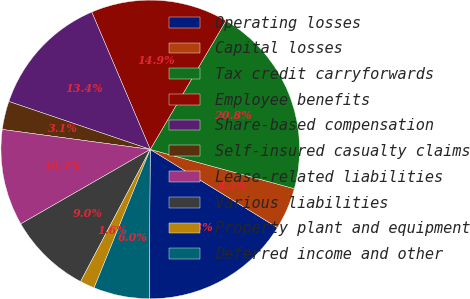Convert chart. <chart><loc_0><loc_0><loc_500><loc_500><pie_chart><fcel>Operating losses<fcel>Capital losses<fcel>Tax credit carryforwards<fcel>Employee benefits<fcel>Share-based compensation<fcel>Self-insured casualty claims<fcel>Lease-related liabilities<fcel>Various liabilities<fcel>Property plant and equipment<fcel>Deferred income and other<nl><fcel>16.34%<fcel>4.54%<fcel>20.77%<fcel>14.87%<fcel>13.39%<fcel>3.07%<fcel>10.44%<fcel>8.97%<fcel>1.59%<fcel>6.02%<nl></chart> 